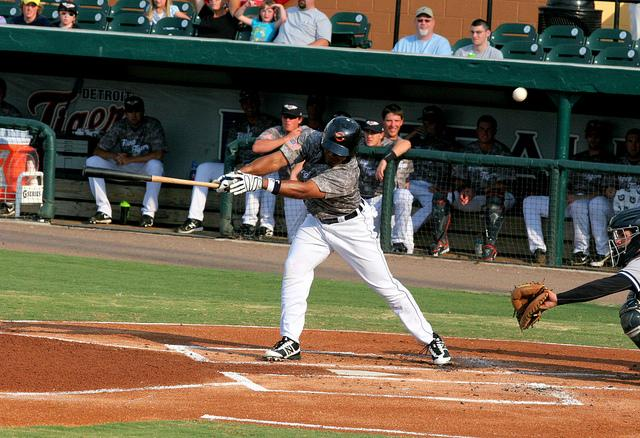What is the man with the bat about to do?

Choices:
A) sit
B) duck
C) swing
D) sing swing 